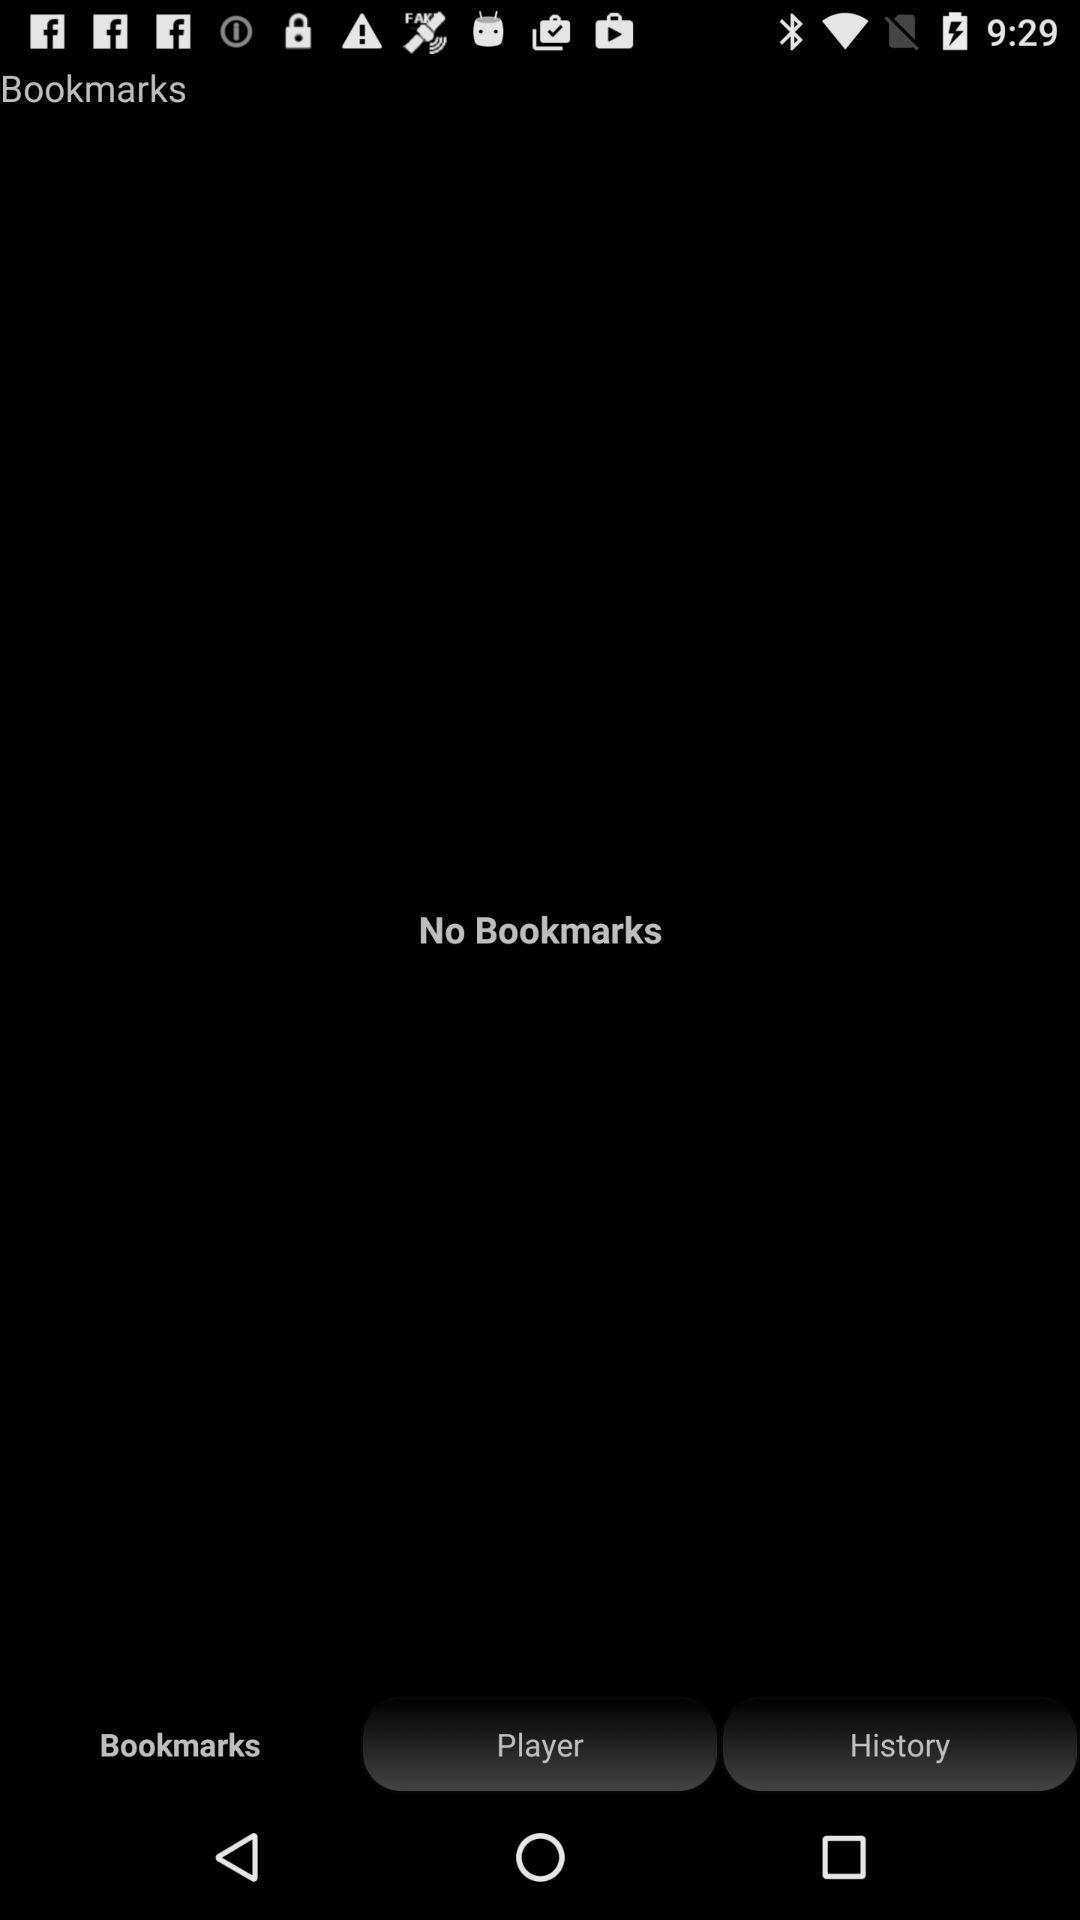Which tab has been selected? The selected tab is "Bookmarks". 